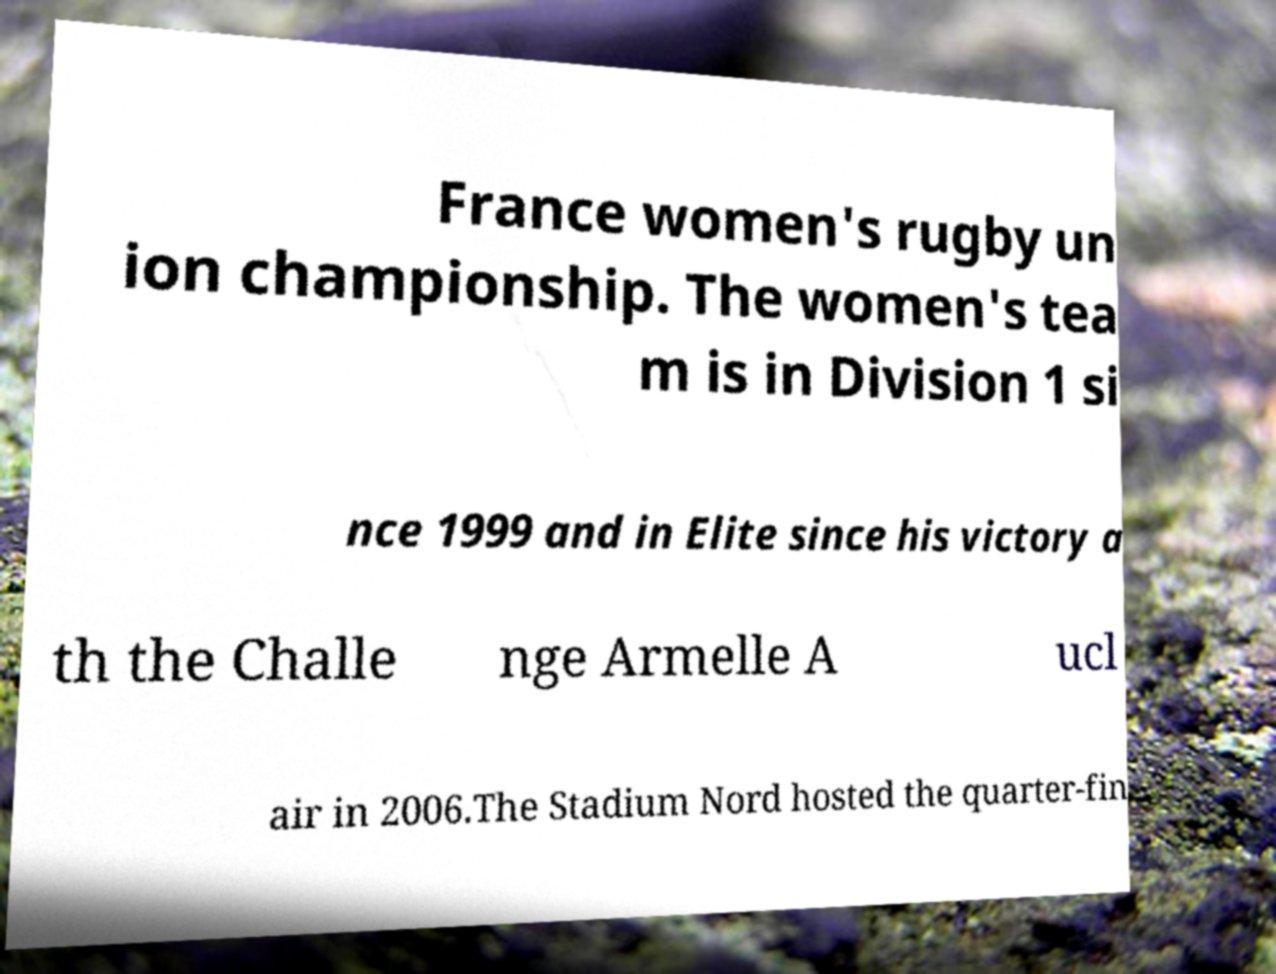For documentation purposes, I need the text within this image transcribed. Could you provide that? France women's rugby un ion championship. The women's tea m is in Division 1 si nce 1999 and in Elite since his victory a th the Challe nge Armelle A ucl air in 2006.The Stadium Nord hosted the quarter-fin 